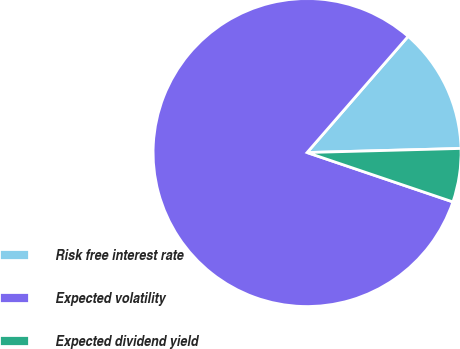Convert chart. <chart><loc_0><loc_0><loc_500><loc_500><pie_chart><fcel>Risk free interest rate<fcel>Expected volatility<fcel>Expected dividend yield<nl><fcel>13.18%<fcel>81.2%<fcel>5.62%<nl></chart> 